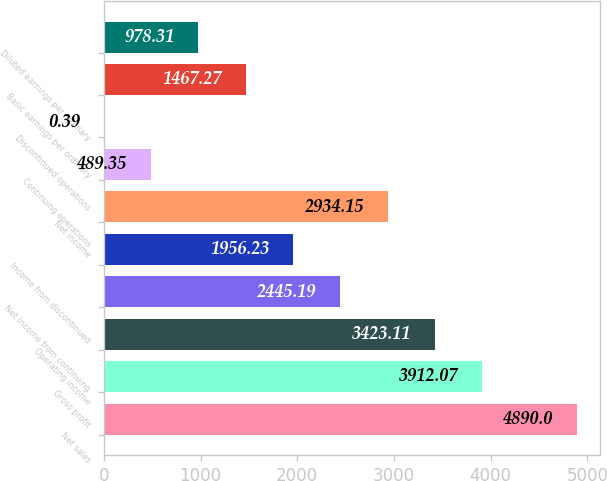Convert chart to OTSL. <chart><loc_0><loc_0><loc_500><loc_500><bar_chart><fcel>Net sales<fcel>Gross profit<fcel>Operating income<fcel>Net income from continuing<fcel>Income from discontinued<fcel>Net income<fcel>Continuing operations<fcel>Discontinued operations<fcel>Basic earnings per ordinary<fcel>Diluted earnings per ordinary<nl><fcel>4890<fcel>3912.07<fcel>3423.11<fcel>2445.19<fcel>1956.23<fcel>2934.15<fcel>489.35<fcel>0.39<fcel>1467.27<fcel>978.31<nl></chart> 